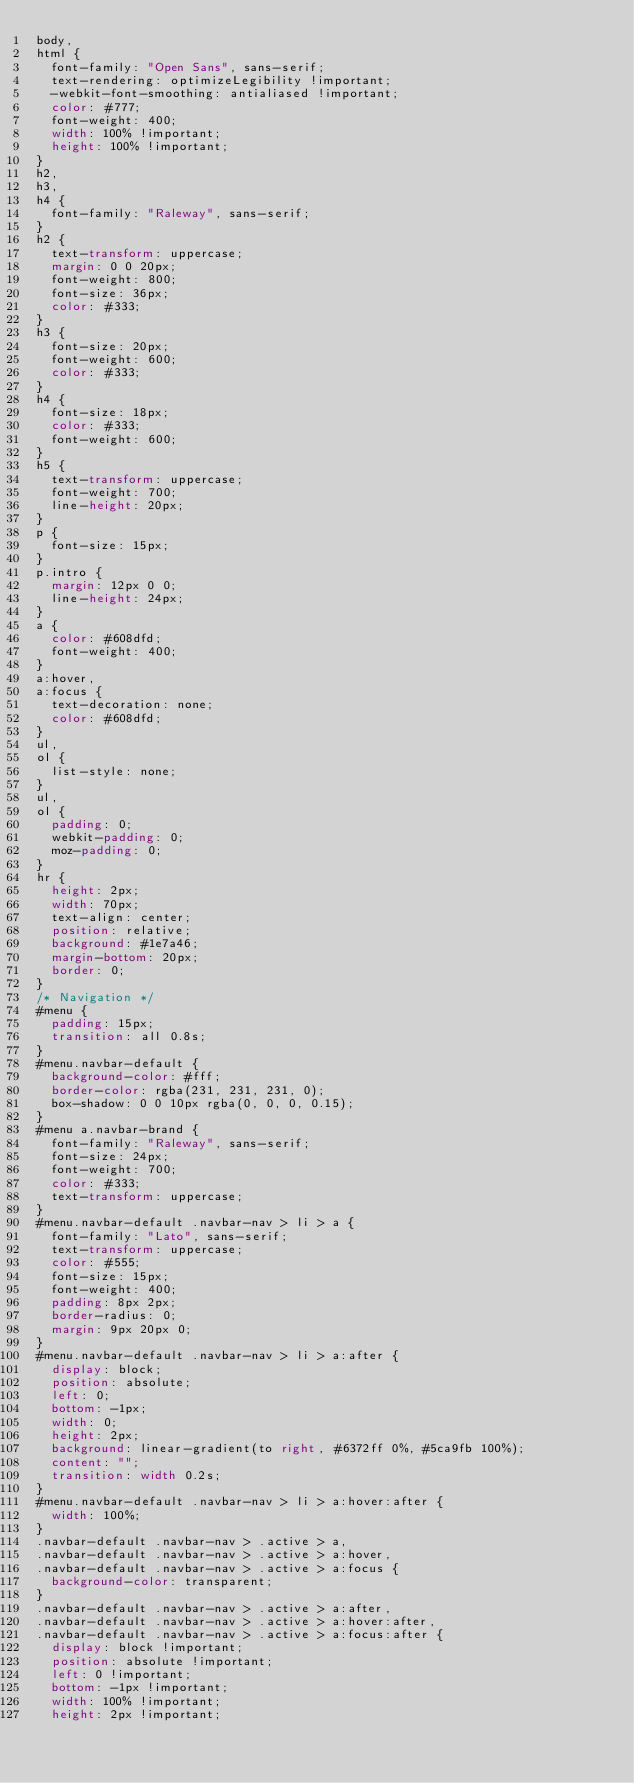<code> <loc_0><loc_0><loc_500><loc_500><_CSS_>body,
html {
  font-family: "Open Sans", sans-serif;
  text-rendering: optimizeLegibility !important;
  -webkit-font-smoothing: antialiased !important;
  color: #777;
  font-weight: 400;
  width: 100% !important;
  height: 100% !important;
}
h2,
h3,
h4 {
  font-family: "Raleway", sans-serif;
}
h2 {
  text-transform: uppercase;
  margin: 0 0 20px;
  font-weight: 800;
  font-size: 36px;
  color: #333;
}
h3 {
  font-size: 20px;
  font-weight: 600;
  color: #333;
}
h4 {
  font-size: 18px;
  color: #333;
  font-weight: 600;
}
h5 {
  text-transform: uppercase;
  font-weight: 700;
  line-height: 20px;
}
p {
  font-size: 15px;
}
p.intro {
  margin: 12px 0 0;
  line-height: 24px;
}
a {
  color: #608dfd;
  font-weight: 400;
}
a:hover,
a:focus {
  text-decoration: none;
  color: #608dfd;
}
ul,
ol {
  list-style: none;
}
ul,
ol {
  padding: 0;
  webkit-padding: 0;
  moz-padding: 0;
}
hr {
  height: 2px;
  width: 70px;
  text-align: center;
  position: relative;
  background: #1e7a46;
  margin-bottom: 20px;
  border: 0;
}
/* Navigation */
#menu {
  padding: 15px;
  transition: all 0.8s;
}
#menu.navbar-default {
  background-color: #fff;
  border-color: rgba(231, 231, 231, 0);
  box-shadow: 0 0 10px rgba(0, 0, 0, 0.15);
}
#menu a.navbar-brand {
  font-family: "Raleway", sans-serif;
  font-size: 24px;
  font-weight: 700;
  color: #333;
  text-transform: uppercase;
}
#menu.navbar-default .navbar-nav > li > a {
  font-family: "Lato", sans-serif;
  text-transform: uppercase;
  color: #555;
  font-size: 15px;
  font-weight: 400;
  padding: 8px 2px;
  border-radius: 0;
  margin: 9px 20px 0;
}
#menu.navbar-default .navbar-nav > li > a:after {
  display: block;
  position: absolute;
  left: 0;
  bottom: -1px;
  width: 0;
  height: 2px;
  background: linear-gradient(to right, #6372ff 0%, #5ca9fb 100%);
  content: "";
  transition: width 0.2s;
}
#menu.navbar-default .navbar-nav > li > a:hover:after {
  width: 100%;
}
.navbar-default .navbar-nav > .active > a,
.navbar-default .navbar-nav > .active > a:hover,
.navbar-default .navbar-nav > .active > a:focus {
  background-color: transparent;
}
.navbar-default .navbar-nav > .active > a:after,
.navbar-default .navbar-nav > .active > a:hover:after,
.navbar-default .navbar-nav > .active > a:focus:after {
  display: block !important;
  position: absolute !important;
  left: 0 !important;
  bottom: -1px !important;
  width: 100% !important;
  height: 2px !important;</code> 